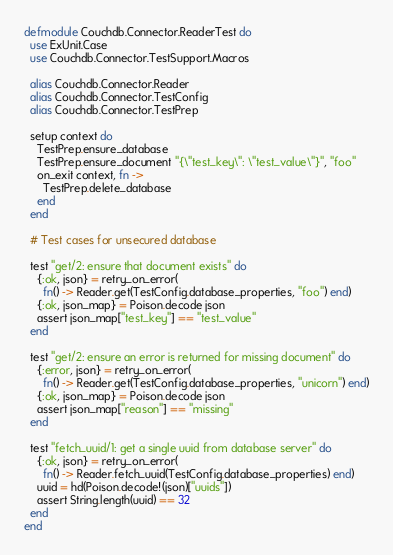Convert code to text. <code><loc_0><loc_0><loc_500><loc_500><_Elixir_>defmodule Couchdb.Connector.ReaderTest do
  use ExUnit.Case
  use Couchdb.Connector.TestSupport.Macros

  alias Couchdb.Connector.Reader
  alias Couchdb.Connector.TestConfig
  alias Couchdb.Connector.TestPrep

  setup context do
    TestPrep.ensure_database
    TestPrep.ensure_document "{\"test_key\": \"test_value\"}", "foo"
    on_exit context, fn ->
      TestPrep.delete_database
    end
  end

  # Test cases for unsecured database

  test "get/2: ensure that document exists" do
    {:ok, json} = retry_on_error(
      fn() -> Reader.get(TestConfig.database_properties, "foo") end)
    {:ok, json_map} = Poison.decode json
    assert json_map["test_key"] == "test_value"
  end

  test "get/2: ensure an error is returned for missing document" do
    {:error, json} = retry_on_error(
      fn() -> Reader.get(TestConfig.database_properties, "unicorn") end)
    {:ok, json_map} = Poison.decode json
    assert json_map["reason"] == "missing"
  end

  test "fetch_uuid/1: get a single uuid from database server" do
    {:ok, json} = retry_on_error(
      fn() -> Reader.fetch_uuid(TestConfig.database_properties) end)
    uuid = hd(Poison.decode!(json)["uuids"])
    assert String.length(uuid) == 32
  end
end
</code> 